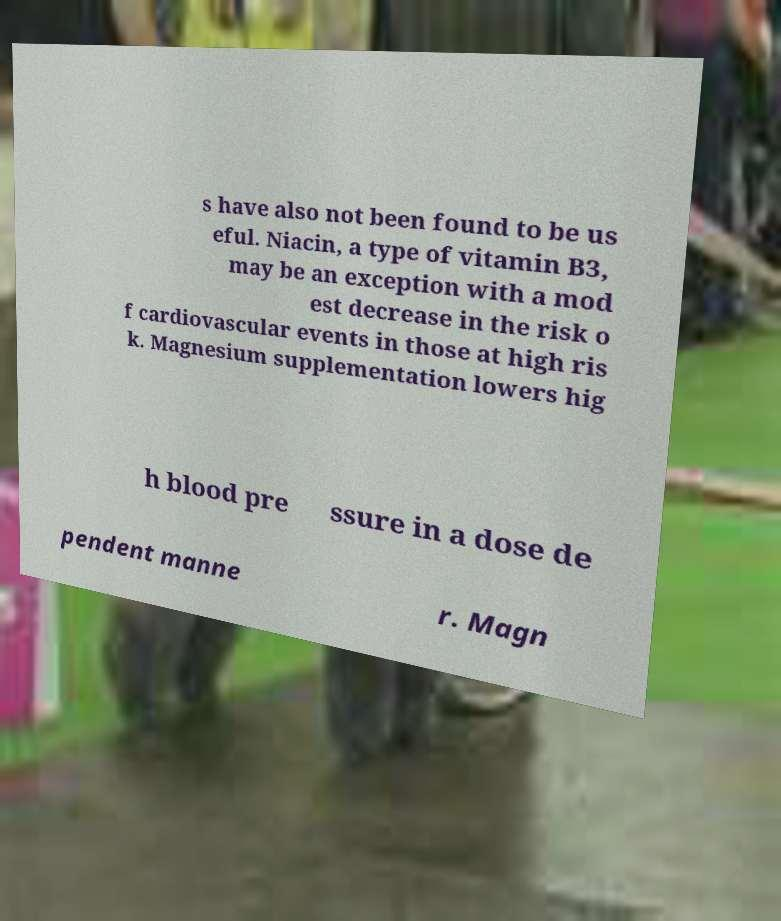I need the written content from this picture converted into text. Can you do that? s have also not been found to be us eful. Niacin, a type of vitamin B3, may be an exception with a mod est decrease in the risk o f cardiovascular events in those at high ris k. Magnesium supplementation lowers hig h blood pre ssure in a dose de pendent manne r. Magn 